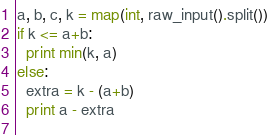Convert code to text. <code><loc_0><loc_0><loc_500><loc_500><_Python_>a, b, c, k = map(int, raw_input().split())
if k <= a+b:
  print min(k, a)
else:
  extra = k - (a+b)
  print a - extra
  </code> 